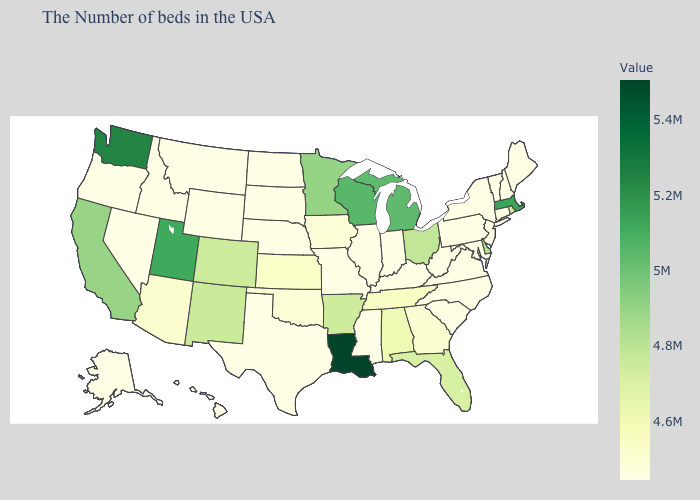Does Georgia have the highest value in the South?
Short answer required. No. Among the states that border Vermont , which have the highest value?
Answer briefly. Massachusetts. Among the states that border Arizona , does California have the highest value?
Quick response, please. No. 